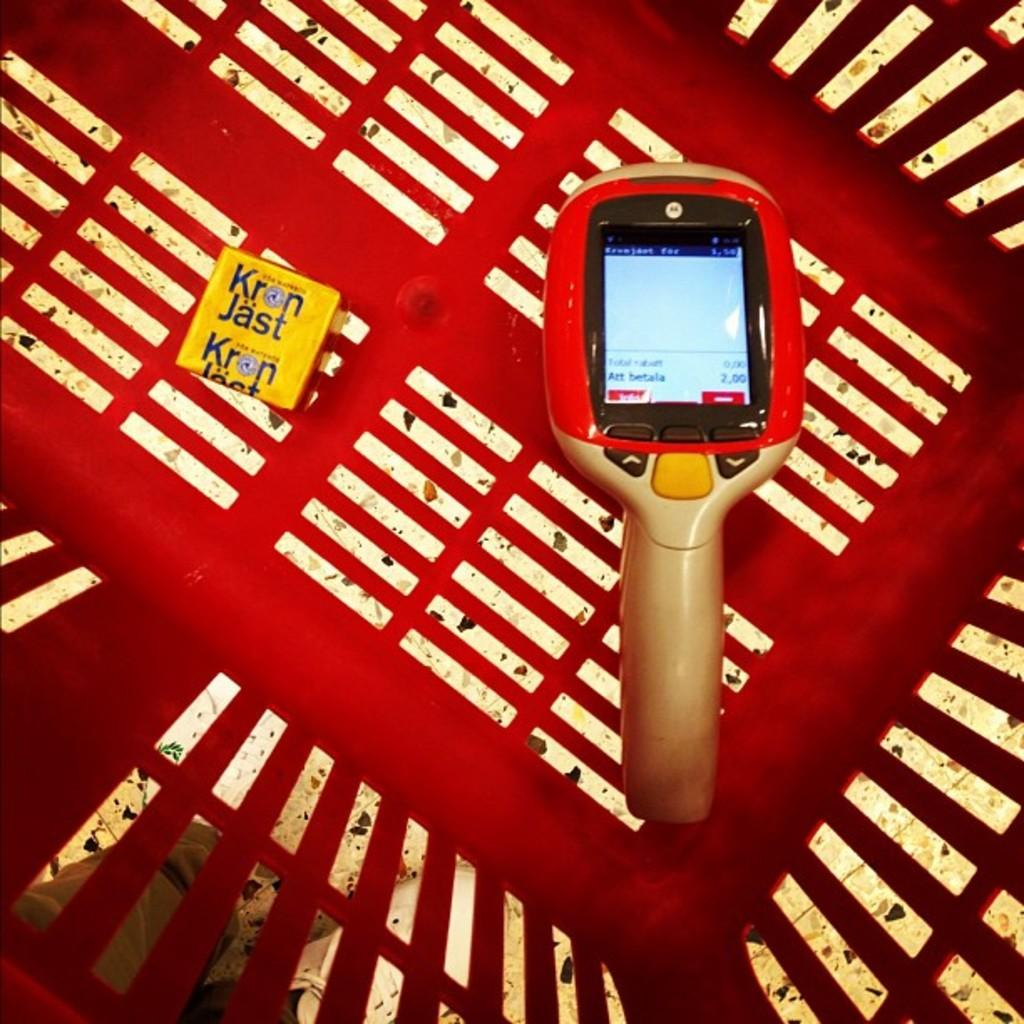What is the main object in the image with a screen? There is a machine with a screen in the image. What other object is present in the image? There is a box in the image. How are the machine and the box positioned in the image? Both the machine and the box are in a basket. Can you describe the person in the image? The person is behind the basket and is wearing shoes. What is the person standing on in the image? The person is standing on the floor. What type of account does the person have with the machine in the image? There is no mention of an account in the image; it only shows a machine with a screen, a box, a basket, and a person standing on the floor. 